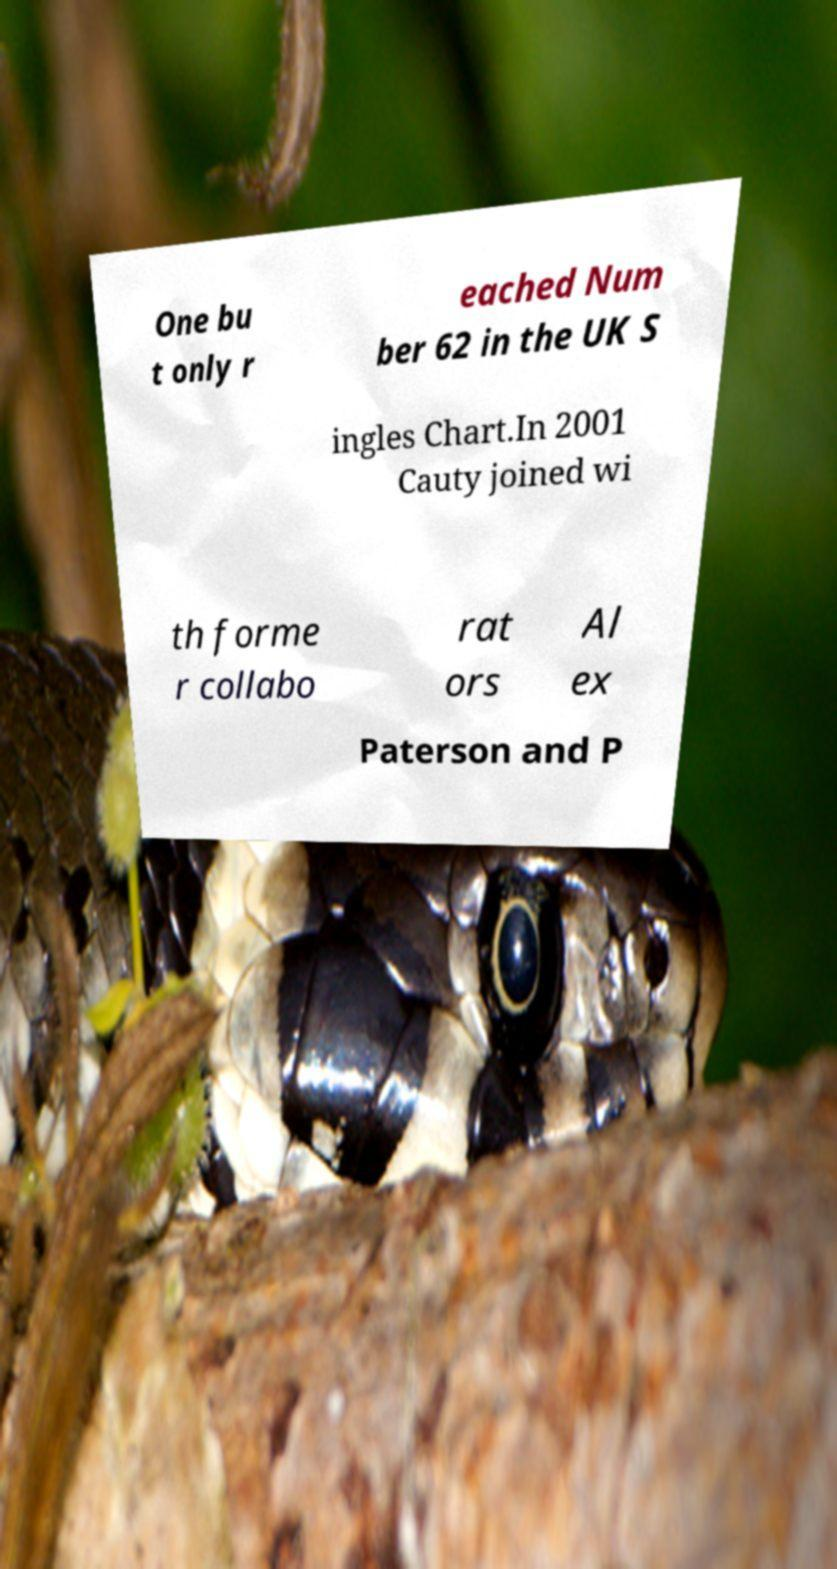Please identify and transcribe the text found in this image. One bu t only r eached Num ber 62 in the UK S ingles Chart.In 2001 Cauty joined wi th forme r collabo rat ors Al ex Paterson and P 